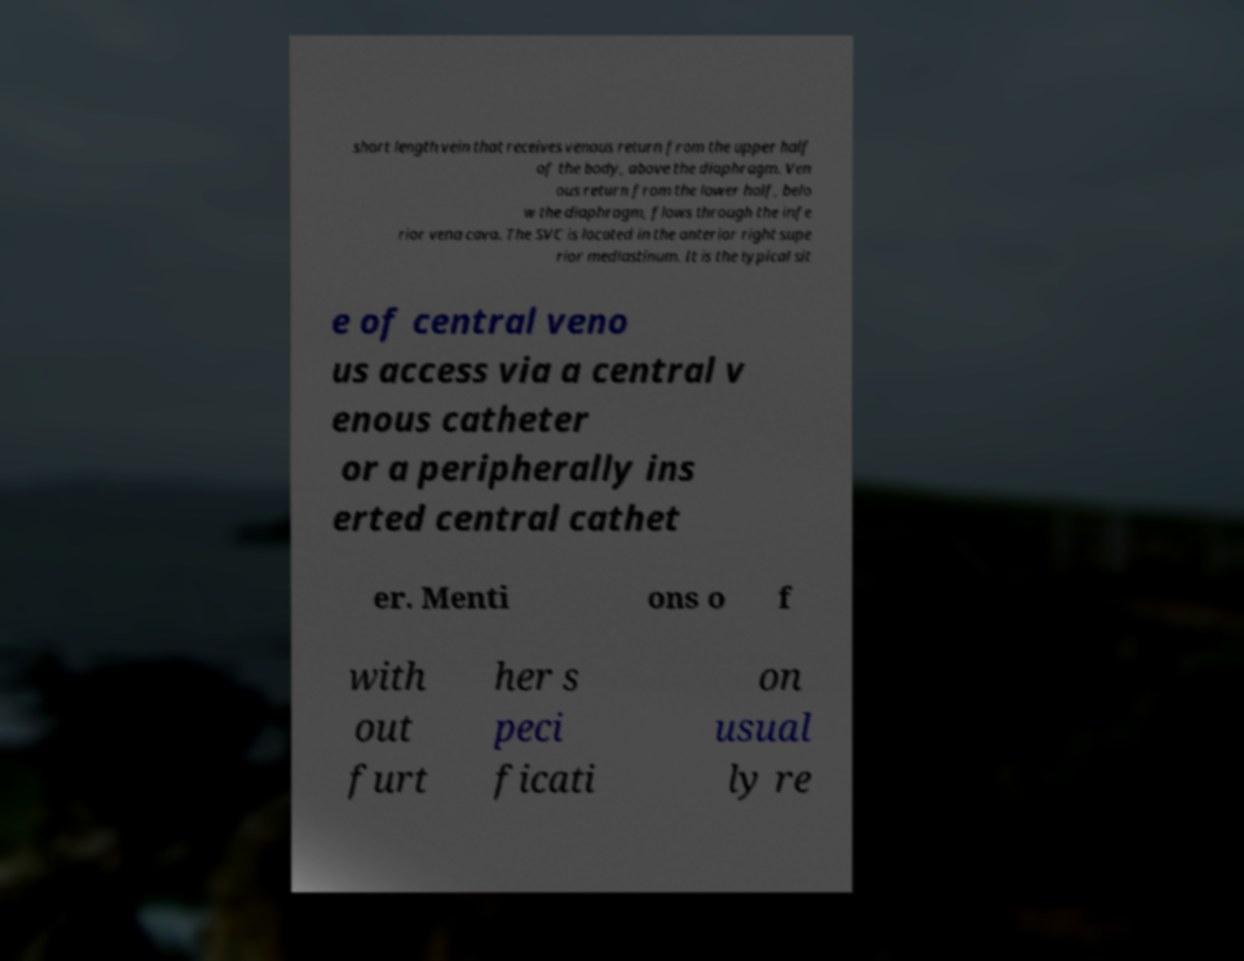Please read and relay the text visible in this image. What does it say? short length vein that receives venous return from the upper half of the body, above the diaphragm. Ven ous return from the lower half, belo w the diaphragm, flows through the infe rior vena cava. The SVC is located in the anterior right supe rior mediastinum. It is the typical sit e of central veno us access via a central v enous catheter or a peripherally ins erted central cathet er. Menti ons o f with out furt her s peci ficati on usual ly re 